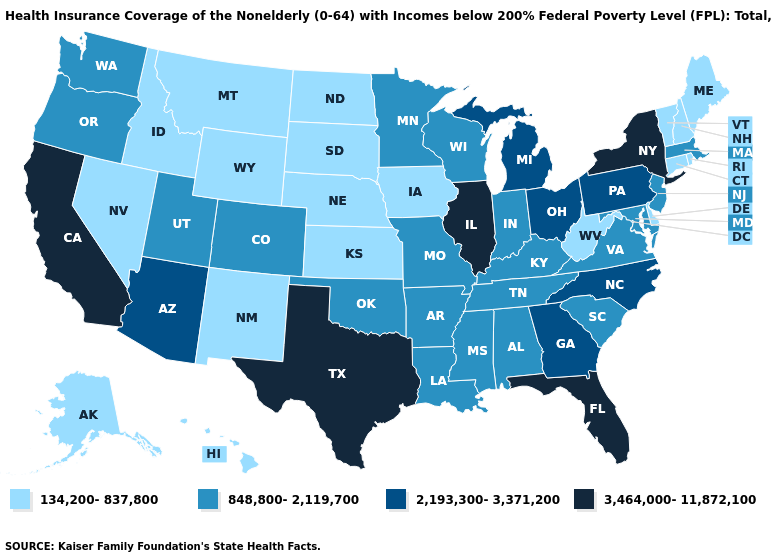Does New Mexico have the same value as South Carolina?
Keep it brief. No. Which states have the lowest value in the West?
Keep it brief. Alaska, Hawaii, Idaho, Montana, Nevada, New Mexico, Wyoming. Name the states that have a value in the range 2,193,300-3,371,200?
Give a very brief answer. Arizona, Georgia, Michigan, North Carolina, Ohio, Pennsylvania. What is the lowest value in the Northeast?
Give a very brief answer. 134,200-837,800. Which states have the lowest value in the MidWest?
Short answer required. Iowa, Kansas, Nebraska, North Dakota, South Dakota. Name the states that have a value in the range 2,193,300-3,371,200?
Keep it brief. Arizona, Georgia, Michigan, North Carolina, Ohio, Pennsylvania. Among the states that border Illinois , does Wisconsin have the highest value?
Be succinct. Yes. Among the states that border Oregon , does Idaho have the lowest value?
Concise answer only. Yes. How many symbols are there in the legend?
Answer briefly. 4. Does Idaho have a lower value than Massachusetts?
Give a very brief answer. Yes. What is the value of Pennsylvania?
Keep it brief. 2,193,300-3,371,200. Name the states that have a value in the range 2,193,300-3,371,200?
Short answer required. Arizona, Georgia, Michigan, North Carolina, Ohio, Pennsylvania. Does Wyoming have the lowest value in the USA?
Short answer required. Yes. Which states have the highest value in the USA?
Answer briefly. California, Florida, Illinois, New York, Texas. What is the value of South Dakota?
Concise answer only. 134,200-837,800. 